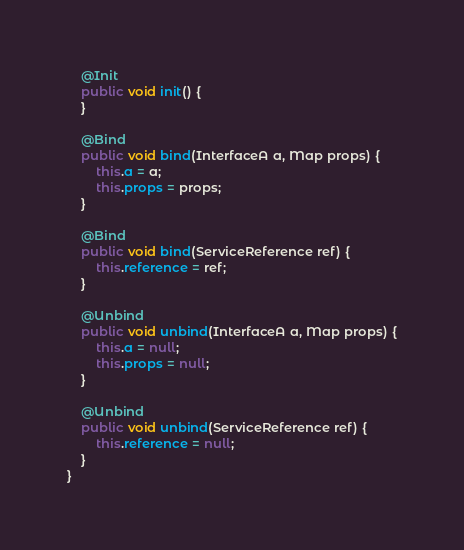<code> <loc_0><loc_0><loc_500><loc_500><_Java_>
    @Init
    public void init() {
    }

    @Bind
    public void bind(InterfaceA a, Map props) {
        this.a = a;
        this.props = props;
    }

    @Bind
    public void bind(ServiceReference ref) {
        this.reference = ref;
    }

    @Unbind
    public void unbind(InterfaceA a, Map props) {
        this.a = null;
        this.props = null;
    }

    @Unbind
    public void unbind(ServiceReference ref) {
        this.reference = null;
    }
}
</code> 